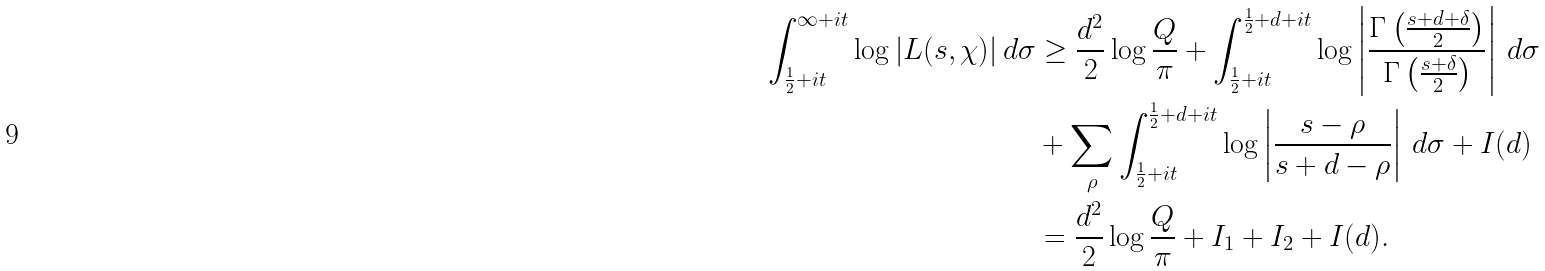Convert formula to latex. <formula><loc_0><loc_0><loc_500><loc_500>\int _ { \frac { 1 } { 2 } + i t } ^ { \infty + i t } \log | L ( s , \chi ) | \, d \sigma & \geq \frac { d ^ { 2 } } { 2 } \log \frac { Q } { \pi } + \int _ { \frac { 1 } { 2 } + i t } ^ { \frac { 1 } { 2 } + d + i t } \log \left | \frac { \Gamma \left ( \frac { s + d + \delta } { 2 } \right ) } { \Gamma \left ( \frac { s + \delta } { 2 } \right ) } \right | \, d \sigma \\ & + \sum _ { \rho } \int _ { \frac { 1 } { 2 } + i t } ^ { \frac { 1 } { 2 } + d + i t } \log \left | \frac { s - \rho } { s + d - \rho } \right | \, d \sigma + I ( d ) \\ & = \frac { d ^ { 2 } } { 2 } \log \frac { Q } { \pi } + I _ { 1 } + I _ { 2 } + I ( d ) .</formula> 